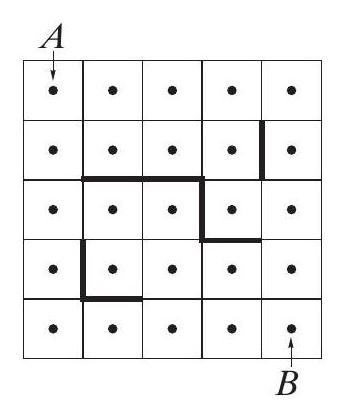Can you explain the rules used to position the obstacles in the grid shown in the image? The obstacles in the grid might be randomly positioned or could follow a specific pattern or rule, such as blocking pathways that simplify the traversal problem. Analyzing their positions might reveal strategic placement intended to increase the complexity of finding the shortest path from A to B, or they might simply represent arbitrary blockages that need to be worked around. 